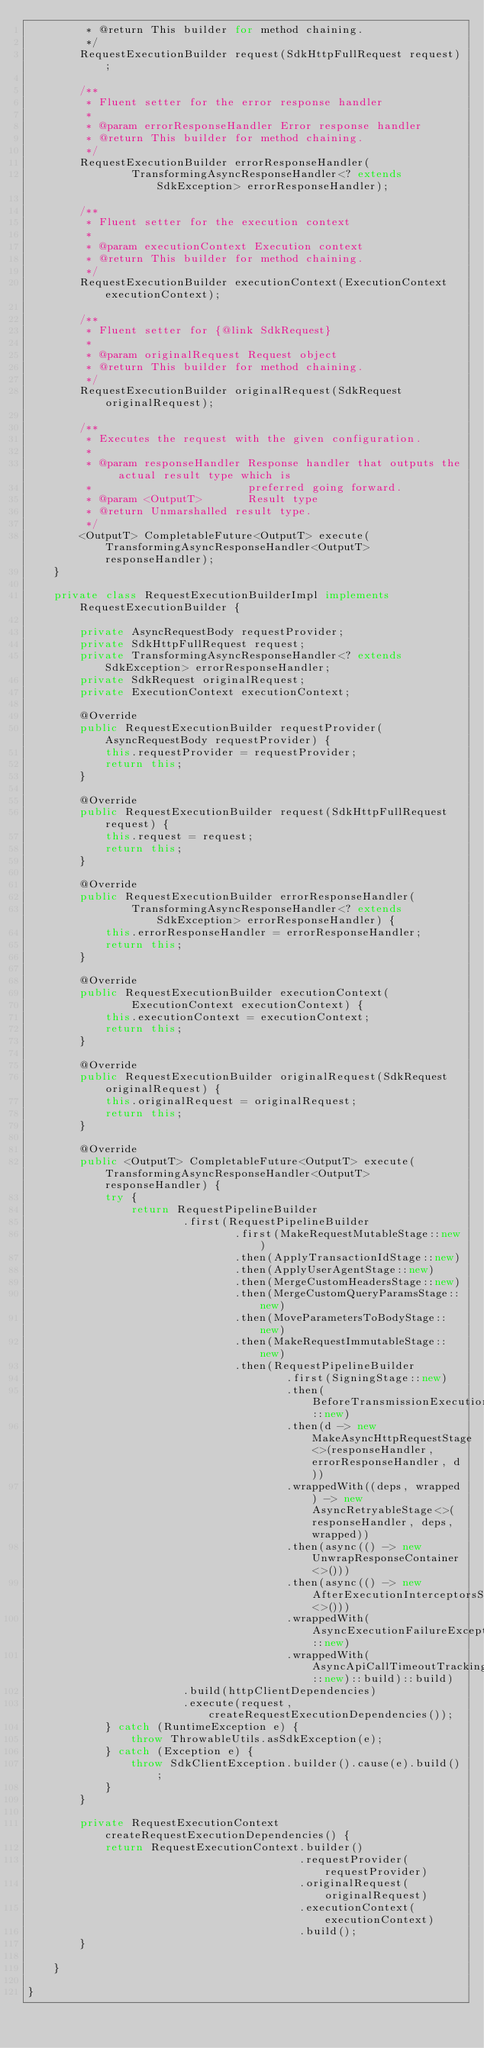Convert code to text. <code><loc_0><loc_0><loc_500><loc_500><_Java_>         * @return This builder for method chaining.
         */
        RequestExecutionBuilder request(SdkHttpFullRequest request);

        /**
         * Fluent setter for the error response handler
         *
         * @param errorResponseHandler Error response handler
         * @return This builder for method chaining.
         */
        RequestExecutionBuilder errorResponseHandler(
                TransformingAsyncResponseHandler<? extends SdkException> errorResponseHandler);

        /**
         * Fluent setter for the execution context
         *
         * @param executionContext Execution context
         * @return This builder for method chaining.
         */
        RequestExecutionBuilder executionContext(ExecutionContext executionContext);

        /**
         * Fluent setter for {@link SdkRequest}
         *
         * @param originalRequest Request object
         * @return This builder for method chaining.
         */
        RequestExecutionBuilder originalRequest(SdkRequest originalRequest);

        /**
         * Executes the request with the given configuration.
         *
         * @param responseHandler Response handler that outputs the actual result type which is
         *                        preferred going forward.
         * @param <OutputT>       Result type
         * @return Unmarshalled result type.
         */
        <OutputT> CompletableFuture<OutputT> execute(TransformingAsyncResponseHandler<OutputT> responseHandler);
    }

    private class RequestExecutionBuilderImpl implements RequestExecutionBuilder {

        private AsyncRequestBody requestProvider;
        private SdkHttpFullRequest request;
        private TransformingAsyncResponseHandler<? extends SdkException> errorResponseHandler;
        private SdkRequest originalRequest;
        private ExecutionContext executionContext;

        @Override
        public RequestExecutionBuilder requestProvider(AsyncRequestBody requestProvider) {
            this.requestProvider = requestProvider;
            return this;
        }

        @Override
        public RequestExecutionBuilder request(SdkHttpFullRequest request) {
            this.request = request;
            return this;
        }

        @Override
        public RequestExecutionBuilder errorResponseHandler(
                TransformingAsyncResponseHandler<? extends SdkException> errorResponseHandler) {
            this.errorResponseHandler = errorResponseHandler;
            return this;
        }

        @Override
        public RequestExecutionBuilder executionContext(
                ExecutionContext executionContext) {
            this.executionContext = executionContext;
            return this;
        }

        @Override
        public RequestExecutionBuilder originalRequest(SdkRequest originalRequest) {
            this.originalRequest = originalRequest;
            return this;
        }

        @Override
        public <OutputT> CompletableFuture<OutputT> execute(TransformingAsyncResponseHandler<OutputT> responseHandler) {
            try {
                return RequestPipelineBuilder
                        .first(RequestPipelineBuilder
                                .first(MakeRequestMutableStage::new)
                                .then(ApplyTransactionIdStage::new)
                                .then(ApplyUserAgentStage::new)
                                .then(MergeCustomHeadersStage::new)
                                .then(MergeCustomQueryParamsStage::new)
                                .then(MoveParametersToBodyStage::new)
                                .then(MakeRequestImmutableStage::new)
                                .then(RequestPipelineBuilder
                                        .first(SigningStage::new)
                                        .then(BeforeTransmissionExecutionInterceptorsStage::new)
                                        .then(d -> new MakeAsyncHttpRequestStage<>(responseHandler, errorResponseHandler, d))
                                        .wrappedWith((deps, wrapped) -> new AsyncRetryableStage<>(responseHandler, deps, wrapped))
                                        .then(async(() -> new UnwrapResponseContainer<>()))
                                        .then(async(() -> new AfterExecutionInterceptorsStage<>()))
                                        .wrappedWith(AsyncExecutionFailureExceptionReportingStage::new)
                                        .wrappedWith(AsyncApiCallTimeoutTrackingStage::new)::build)::build)
                        .build(httpClientDependencies)
                        .execute(request, createRequestExecutionDependencies());
            } catch (RuntimeException e) {
                throw ThrowableUtils.asSdkException(e);
            } catch (Exception e) {
                throw SdkClientException.builder().cause(e).build();
            }
        }

        private RequestExecutionContext createRequestExecutionDependencies() {
            return RequestExecutionContext.builder()
                                          .requestProvider(requestProvider)
                                          .originalRequest(originalRequest)
                                          .executionContext(executionContext)
                                          .build();
        }

    }

}
</code> 